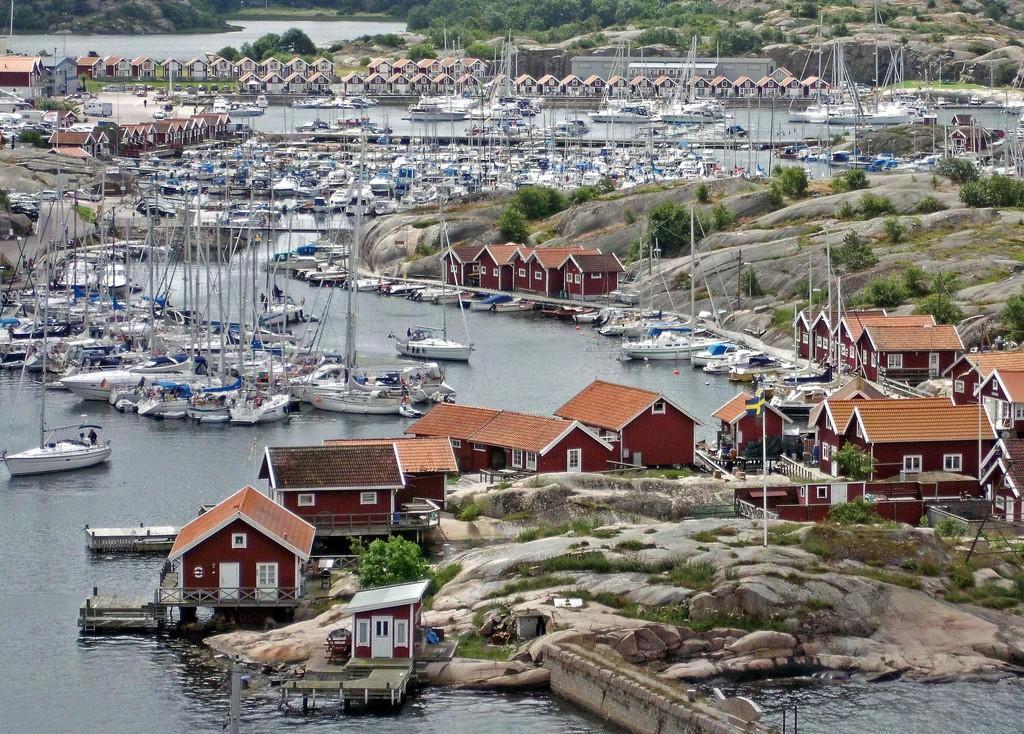How would you summarize this image in a sentence or two? In this image we can see sheds. In the center there is a river and we can see ships. In the background there are trees and a hill. 